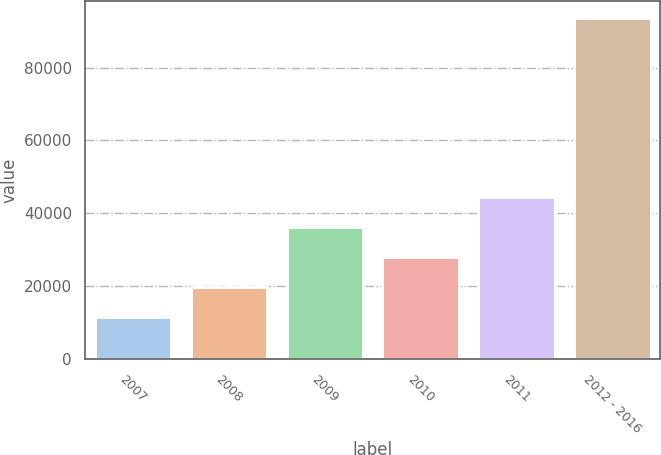Convert chart to OTSL. <chart><loc_0><loc_0><loc_500><loc_500><bar_chart><fcel>2007<fcel>2008<fcel>2009<fcel>2010<fcel>2011<fcel>2012 - 2016<nl><fcel>11632<fcel>19834<fcel>36238<fcel>28036<fcel>44440<fcel>93652<nl></chart> 